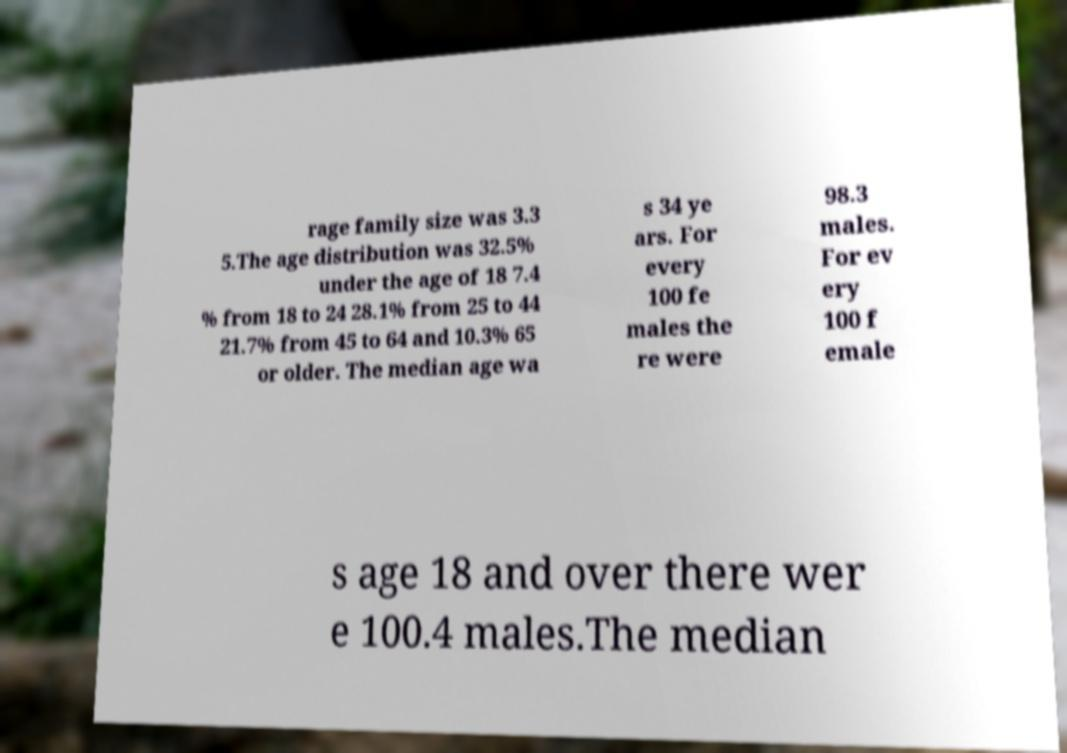I need the written content from this picture converted into text. Can you do that? rage family size was 3.3 5.The age distribution was 32.5% under the age of 18 7.4 % from 18 to 24 28.1% from 25 to 44 21.7% from 45 to 64 and 10.3% 65 or older. The median age wa s 34 ye ars. For every 100 fe males the re were 98.3 males. For ev ery 100 f emale s age 18 and over there wer e 100.4 males.The median 